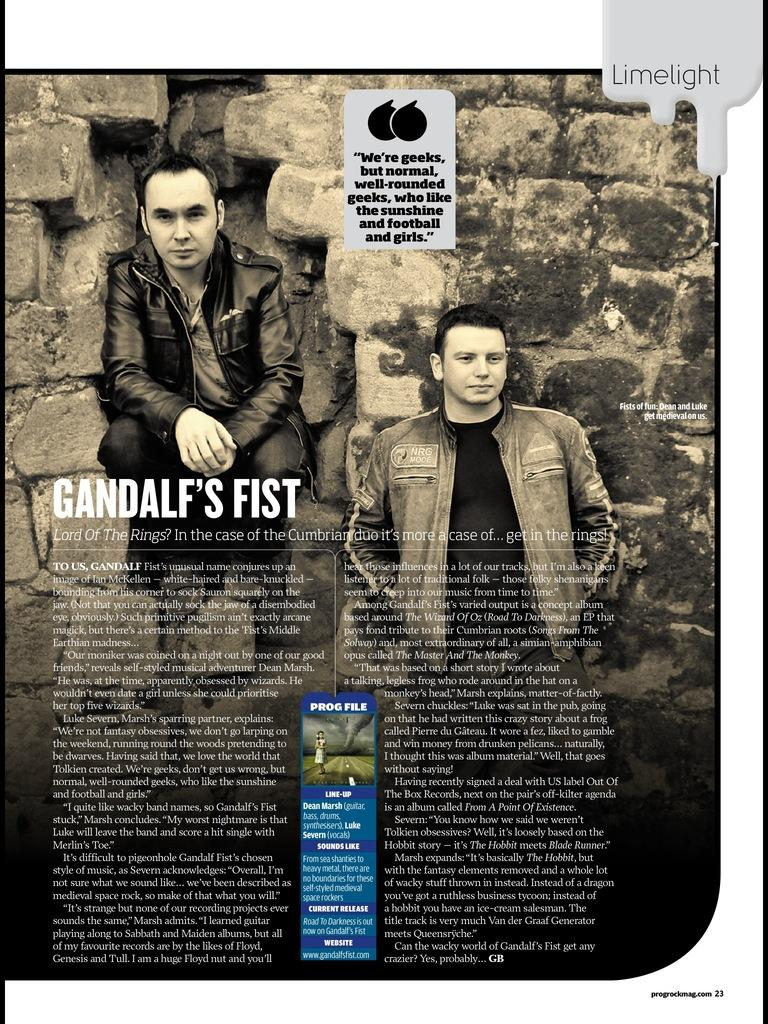What can be seen hanging on the wall in the image? There is a poster in the image. How many people are present in the image? There are two men in the image. What is written or printed in the image? There is text in the image. What is visible behind the men in the image? There is a wall in the background of the image. What role does the father play in the image? There is no mention of a father or any familial relationships in the image. How does the actor change their appearance in the image? There is no actor present in the image, so it is not possible to discuss any changes in appearance. 